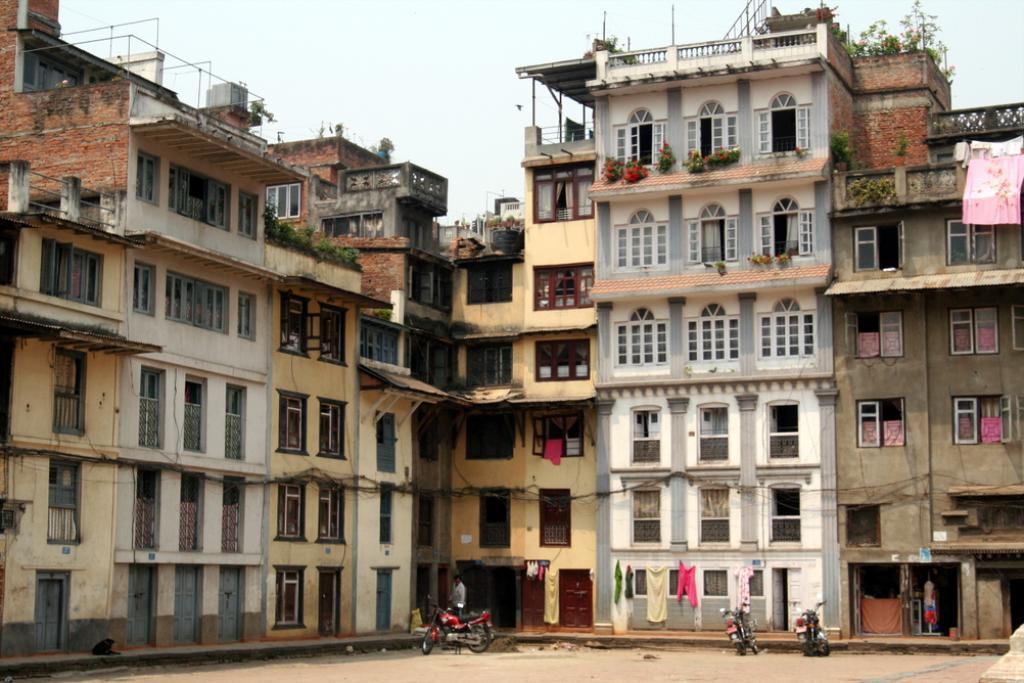What type of structures can be seen in the image? There are buildings in the image. What feature do the buildings have? The buildings have windows. What else can be seen in the image besides buildings? There are vehicles, plants and flowers, and clothes visible in the image. What is visible in the background of the image? The sky is visible in the background of the image. What does the regret in the image? There is no regret present in the image. 